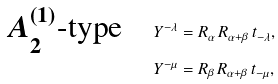Convert formula to latex. <formula><loc_0><loc_0><loc_500><loc_500>\text {$A^{(1)}_{2}$-type} \quad & Y ^ { - \lambda } = R _ { \alpha } \, R _ { \alpha + \beta } \, t _ { - \lambda } , \\ & Y ^ { - \mu } = R _ { \beta } \, R _ { \alpha + \beta } \, t _ { - \mu } ,</formula> 